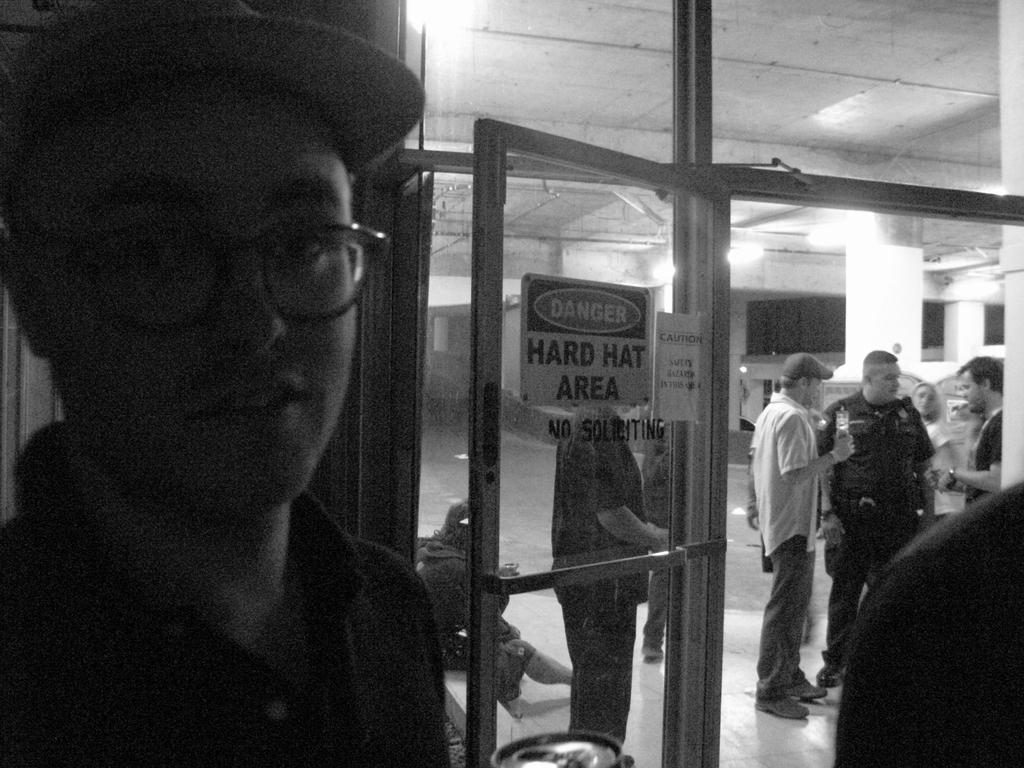What is the main subject of the image? The main subject of the image is a boy standing. Can you describe the boy's appearance? The boy is wearing glasses (specs). Are there any other people in the image? Yes, there are people standing in the image. What else can be seen in the image? There are lights visible in the image. What type of egg is being cooked in the image? There is no egg present in the image; it features a boy standing and other people. Can you see any smoke coming from the egg in the image? There is no egg or smoke present in the image. 